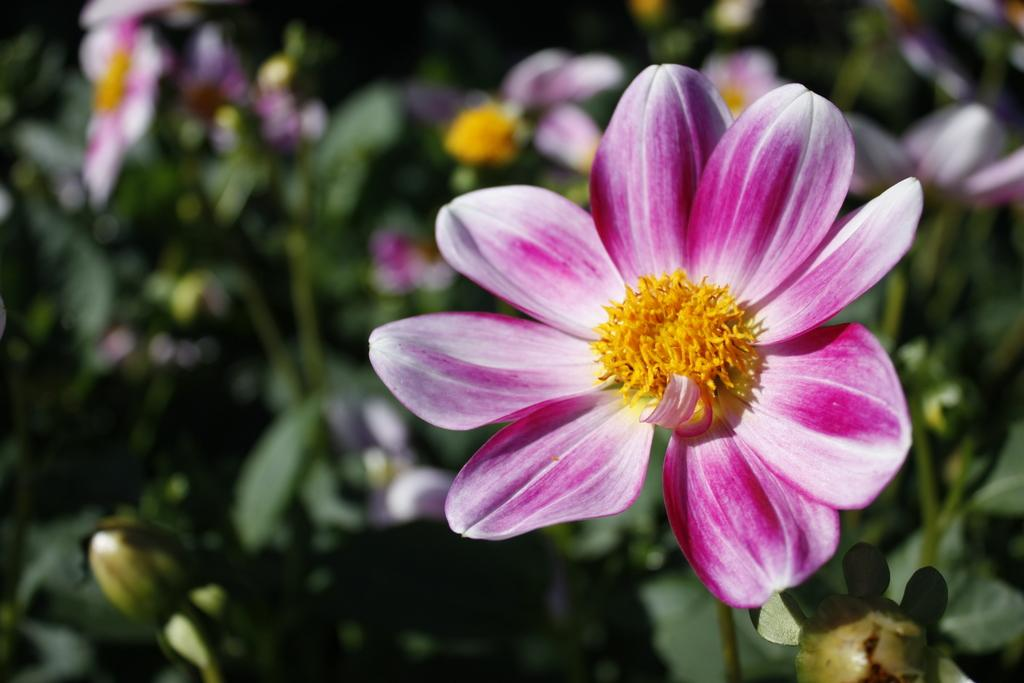What is located in the center of the image? There are plants in the center of the image. What type of plants are present in the image? There are flowers in the image. What colors can be seen in the flowers? The flowers are in pink, white, and yellow colors. Where is the battle taking place in the image? There is no battle present in the image; it features plants and flowers. What type of stage is set up for the performance in the image? There is no stage or performance present in the image; it features plants and flowers. 